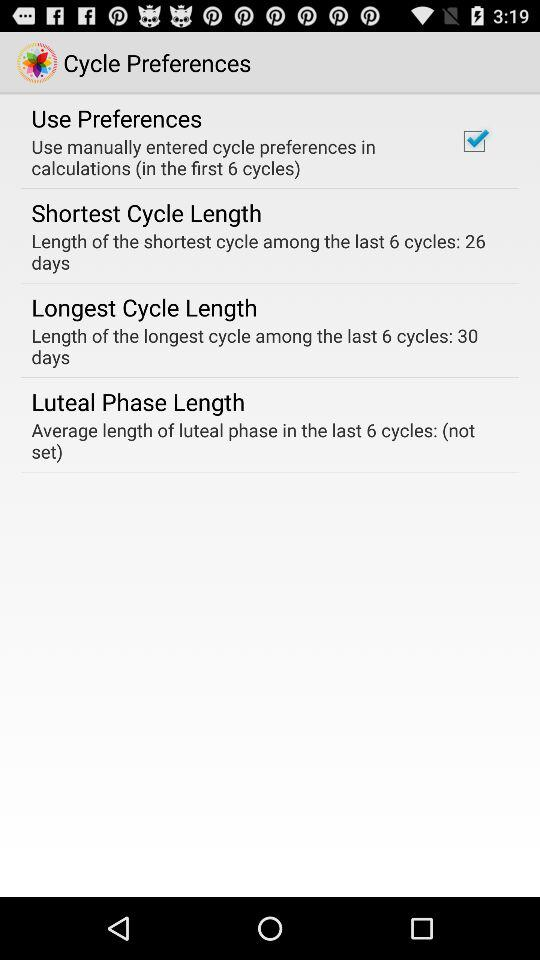What is the average length of the luteal phase in the last 6 cycles? The average length of luteal phase in last 6 cycles is "(not set)". 